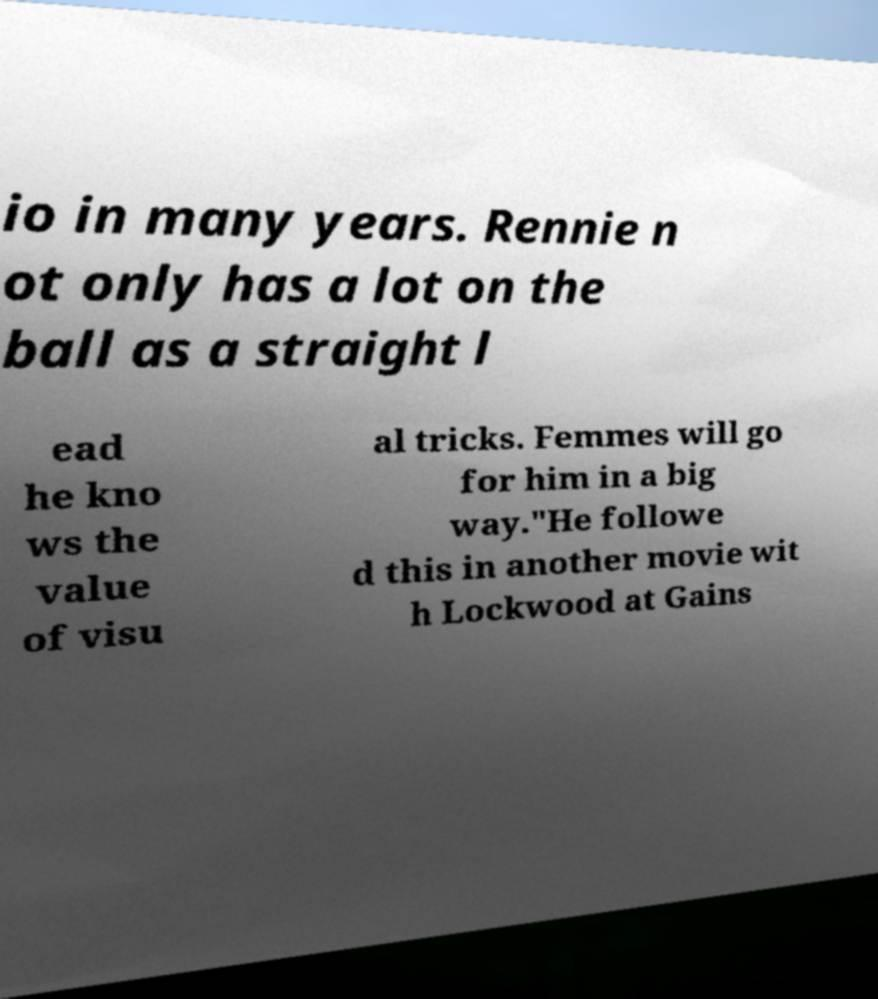Please read and relay the text visible in this image. What does it say? io in many years. Rennie n ot only has a lot on the ball as a straight l ead he kno ws the value of visu al tricks. Femmes will go for him in a big way."He followe d this in another movie wit h Lockwood at Gains 